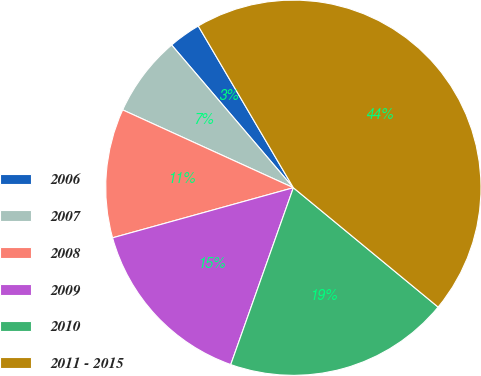Convert chart. <chart><loc_0><loc_0><loc_500><loc_500><pie_chart><fcel>2006<fcel>2007<fcel>2008<fcel>2009<fcel>2010<fcel>2011 - 2015<nl><fcel>2.78%<fcel>6.95%<fcel>11.11%<fcel>15.28%<fcel>19.44%<fcel>44.43%<nl></chart> 